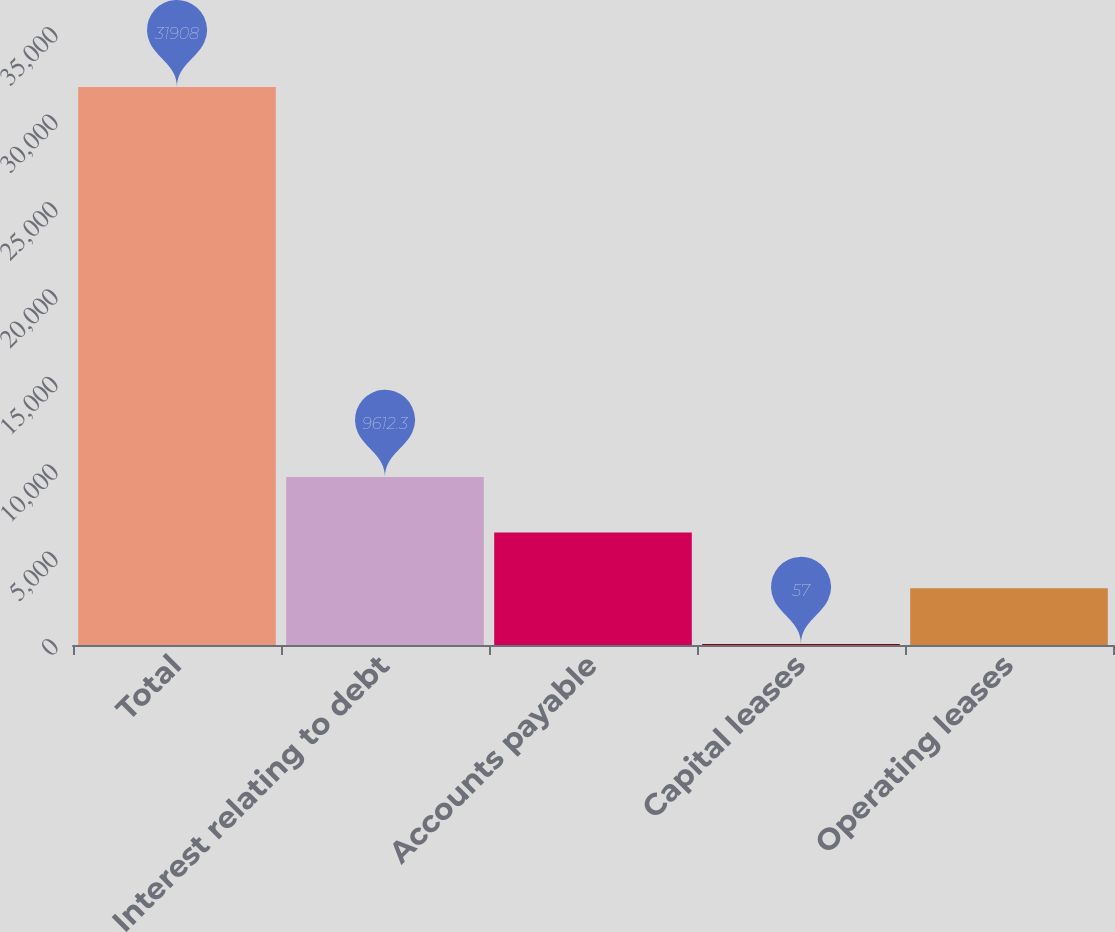Convert chart to OTSL. <chart><loc_0><loc_0><loc_500><loc_500><bar_chart><fcel>Total<fcel>Interest relating to debt<fcel>Accounts payable<fcel>Capital leases<fcel>Operating leases<nl><fcel>31908<fcel>9612.3<fcel>6427.2<fcel>57<fcel>3242.1<nl></chart> 